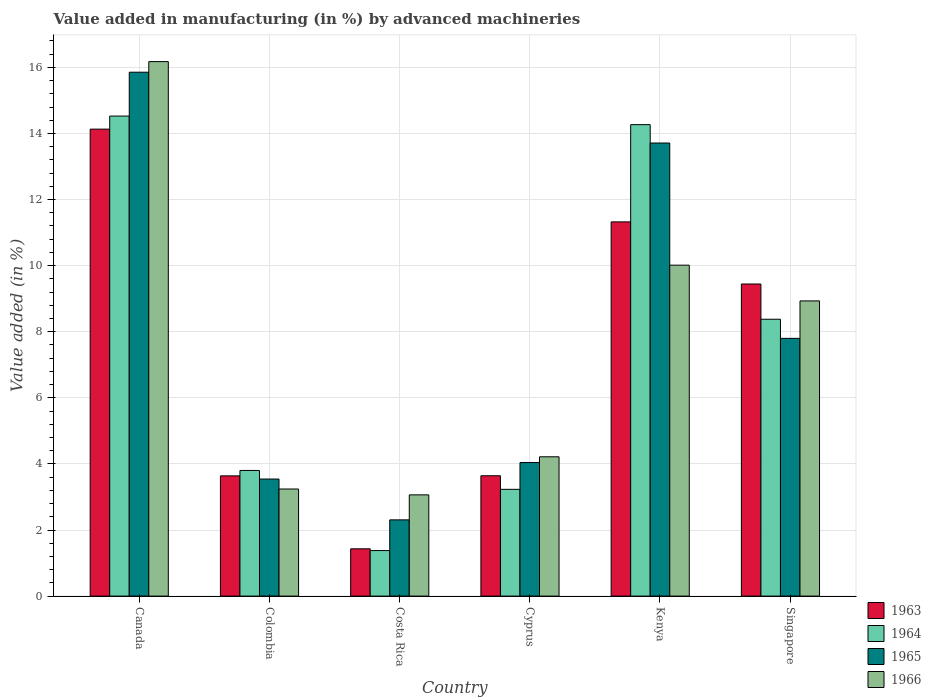How many different coloured bars are there?
Your response must be concise. 4. How many groups of bars are there?
Offer a very short reply. 6. Are the number of bars on each tick of the X-axis equal?
Offer a terse response. Yes. What is the label of the 6th group of bars from the left?
Keep it short and to the point. Singapore. In how many cases, is the number of bars for a given country not equal to the number of legend labels?
Your response must be concise. 0. What is the percentage of value added in manufacturing by advanced machineries in 1963 in Canada?
Give a very brief answer. 14.13. Across all countries, what is the maximum percentage of value added in manufacturing by advanced machineries in 1963?
Provide a short and direct response. 14.13. Across all countries, what is the minimum percentage of value added in manufacturing by advanced machineries in 1966?
Make the answer very short. 3.06. In which country was the percentage of value added in manufacturing by advanced machineries in 1963 minimum?
Provide a short and direct response. Costa Rica. What is the total percentage of value added in manufacturing by advanced machineries in 1966 in the graph?
Make the answer very short. 45.64. What is the difference between the percentage of value added in manufacturing by advanced machineries in 1963 in Canada and that in Cyprus?
Make the answer very short. 10.49. What is the difference between the percentage of value added in manufacturing by advanced machineries in 1966 in Costa Rica and the percentage of value added in manufacturing by advanced machineries in 1964 in Colombia?
Your answer should be very brief. -0.74. What is the average percentage of value added in manufacturing by advanced machineries in 1965 per country?
Ensure brevity in your answer.  7.88. What is the difference between the percentage of value added in manufacturing by advanced machineries of/in 1964 and percentage of value added in manufacturing by advanced machineries of/in 1963 in Canada?
Provide a short and direct response. 0.4. In how many countries, is the percentage of value added in manufacturing by advanced machineries in 1964 greater than 11.2 %?
Ensure brevity in your answer.  2. What is the ratio of the percentage of value added in manufacturing by advanced machineries in 1966 in Canada to that in Kenya?
Offer a very short reply. 1.62. What is the difference between the highest and the second highest percentage of value added in manufacturing by advanced machineries in 1963?
Ensure brevity in your answer.  -1.88. What is the difference between the highest and the lowest percentage of value added in manufacturing by advanced machineries in 1964?
Provide a short and direct response. 13.15. Is it the case that in every country, the sum of the percentage of value added in manufacturing by advanced machineries in 1966 and percentage of value added in manufacturing by advanced machineries in 1964 is greater than the sum of percentage of value added in manufacturing by advanced machineries in 1965 and percentage of value added in manufacturing by advanced machineries in 1963?
Your answer should be compact. No. What does the 3rd bar from the left in Colombia represents?
Your response must be concise. 1965. What does the 2nd bar from the right in Costa Rica represents?
Give a very brief answer. 1965. How many bars are there?
Your answer should be very brief. 24. How many countries are there in the graph?
Offer a terse response. 6. Does the graph contain grids?
Offer a terse response. Yes. How are the legend labels stacked?
Keep it short and to the point. Vertical. What is the title of the graph?
Ensure brevity in your answer.  Value added in manufacturing (in %) by advanced machineries. What is the label or title of the Y-axis?
Your response must be concise. Value added (in %). What is the Value added (in %) of 1963 in Canada?
Your answer should be very brief. 14.13. What is the Value added (in %) of 1964 in Canada?
Keep it short and to the point. 14.53. What is the Value added (in %) in 1965 in Canada?
Provide a short and direct response. 15.85. What is the Value added (in %) of 1966 in Canada?
Your answer should be compact. 16.17. What is the Value added (in %) in 1963 in Colombia?
Offer a very short reply. 3.64. What is the Value added (in %) of 1964 in Colombia?
Offer a terse response. 3.8. What is the Value added (in %) in 1965 in Colombia?
Your answer should be very brief. 3.54. What is the Value added (in %) in 1966 in Colombia?
Keep it short and to the point. 3.24. What is the Value added (in %) in 1963 in Costa Rica?
Make the answer very short. 1.43. What is the Value added (in %) of 1964 in Costa Rica?
Your answer should be compact. 1.38. What is the Value added (in %) of 1965 in Costa Rica?
Make the answer very short. 2.31. What is the Value added (in %) of 1966 in Costa Rica?
Your response must be concise. 3.06. What is the Value added (in %) of 1963 in Cyprus?
Offer a terse response. 3.64. What is the Value added (in %) in 1964 in Cyprus?
Ensure brevity in your answer.  3.23. What is the Value added (in %) of 1965 in Cyprus?
Offer a very short reply. 4.04. What is the Value added (in %) in 1966 in Cyprus?
Your response must be concise. 4.22. What is the Value added (in %) in 1963 in Kenya?
Your answer should be very brief. 11.32. What is the Value added (in %) in 1964 in Kenya?
Provide a succinct answer. 14.27. What is the Value added (in %) of 1965 in Kenya?
Provide a succinct answer. 13.71. What is the Value added (in %) of 1966 in Kenya?
Provide a succinct answer. 10.01. What is the Value added (in %) of 1963 in Singapore?
Keep it short and to the point. 9.44. What is the Value added (in %) of 1964 in Singapore?
Give a very brief answer. 8.38. What is the Value added (in %) of 1965 in Singapore?
Make the answer very short. 7.8. What is the Value added (in %) in 1966 in Singapore?
Keep it short and to the point. 8.93. Across all countries, what is the maximum Value added (in %) of 1963?
Offer a terse response. 14.13. Across all countries, what is the maximum Value added (in %) of 1964?
Give a very brief answer. 14.53. Across all countries, what is the maximum Value added (in %) in 1965?
Your answer should be compact. 15.85. Across all countries, what is the maximum Value added (in %) in 1966?
Provide a succinct answer. 16.17. Across all countries, what is the minimum Value added (in %) of 1963?
Your answer should be compact. 1.43. Across all countries, what is the minimum Value added (in %) of 1964?
Your answer should be compact. 1.38. Across all countries, what is the minimum Value added (in %) of 1965?
Give a very brief answer. 2.31. Across all countries, what is the minimum Value added (in %) of 1966?
Offer a very short reply. 3.06. What is the total Value added (in %) in 1963 in the graph?
Offer a very short reply. 43.61. What is the total Value added (in %) in 1964 in the graph?
Provide a short and direct response. 45.58. What is the total Value added (in %) of 1965 in the graph?
Your answer should be compact. 47.25. What is the total Value added (in %) of 1966 in the graph?
Offer a terse response. 45.64. What is the difference between the Value added (in %) of 1963 in Canada and that in Colombia?
Make the answer very short. 10.49. What is the difference between the Value added (in %) in 1964 in Canada and that in Colombia?
Offer a very short reply. 10.72. What is the difference between the Value added (in %) in 1965 in Canada and that in Colombia?
Your response must be concise. 12.31. What is the difference between the Value added (in %) in 1966 in Canada and that in Colombia?
Provide a succinct answer. 12.93. What is the difference between the Value added (in %) of 1963 in Canada and that in Costa Rica?
Provide a short and direct response. 12.7. What is the difference between the Value added (in %) in 1964 in Canada and that in Costa Rica?
Offer a very short reply. 13.15. What is the difference between the Value added (in %) in 1965 in Canada and that in Costa Rica?
Offer a terse response. 13.55. What is the difference between the Value added (in %) of 1966 in Canada and that in Costa Rica?
Make the answer very short. 13.11. What is the difference between the Value added (in %) in 1963 in Canada and that in Cyprus?
Your response must be concise. 10.49. What is the difference between the Value added (in %) of 1964 in Canada and that in Cyprus?
Provide a succinct answer. 11.3. What is the difference between the Value added (in %) of 1965 in Canada and that in Cyprus?
Provide a short and direct response. 11.81. What is the difference between the Value added (in %) of 1966 in Canada and that in Cyprus?
Give a very brief answer. 11.96. What is the difference between the Value added (in %) of 1963 in Canada and that in Kenya?
Provide a short and direct response. 2.81. What is the difference between the Value added (in %) in 1964 in Canada and that in Kenya?
Your answer should be very brief. 0.26. What is the difference between the Value added (in %) in 1965 in Canada and that in Kenya?
Ensure brevity in your answer.  2.14. What is the difference between the Value added (in %) of 1966 in Canada and that in Kenya?
Your answer should be compact. 6.16. What is the difference between the Value added (in %) in 1963 in Canada and that in Singapore?
Keep it short and to the point. 4.69. What is the difference between the Value added (in %) of 1964 in Canada and that in Singapore?
Make the answer very short. 6.15. What is the difference between the Value added (in %) in 1965 in Canada and that in Singapore?
Offer a terse response. 8.05. What is the difference between the Value added (in %) of 1966 in Canada and that in Singapore?
Offer a very short reply. 7.24. What is the difference between the Value added (in %) in 1963 in Colombia and that in Costa Rica?
Offer a terse response. 2.21. What is the difference between the Value added (in %) in 1964 in Colombia and that in Costa Rica?
Your answer should be very brief. 2.42. What is the difference between the Value added (in %) of 1965 in Colombia and that in Costa Rica?
Your answer should be very brief. 1.24. What is the difference between the Value added (in %) of 1966 in Colombia and that in Costa Rica?
Give a very brief answer. 0.18. What is the difference between the Value added (in %) in 1963 in Colombia and that in Cyprus?
Provide a succinct answer. -0. What is the difference between the Value added (in %) of 1964 in Colombia and that in Cyprus?
Provide a short and direct response. 0.57. What is the difference between the Value added (in %) of 1965 in Colombia and that in Cyprus?
Make the answer very short. -0.5. What is the difference between the Value added (in %) in 1966 in Colombia and that in Cyprus?
Ensure brevity in your answer.  -0.97. What is the difference between the Value added (in %) in 1963 in Colombia and that in Kenya?
Your answer should be very brief. -7.69. What is the difference between the Value added (in %) of 1964 in Colombia and that in Kenya?
Give a very brief answer. -10.47. What is the difference between the Value added (in %) in 1965 in Colombia and that in Kenya?
Provide a short and direct response. -10.17. What is the difference between the Value added (in %) in 1966 in Colombia and that in Kenya?
Your response must be concise. -6.77. What is the difference between the Value added (in %) of 1963 in Colombia and that in Singapore?
Give a very brief answer. -5.81. What is the difference between the Value added (in %) of 1964 in Colombia and that in Singapore?
Offer a terse response. -4.58. What is the difference between the Value added (in %) of 1965 in Colombia and that in Singapore?
Your response must be concise. -4.26. What is the difference between the Value added (in %) of 1966 in Colombia and that in Singapore?
Give a very brief answer. -5.69. What is the difference between the Value added (in %) of 1963 in Costa Rica and that in Cyprus?
Your answer should be very brief. -2.21. What is the difference between the Value added (in %) of 1964 in Costa Rica and that in Cyprus?
Make the answer very short. -1.85. What is the difference between the Value added (in %) of 1965 in Costa Rica and that in Cyprus?
Give a very brief answer. -1.73. What is the difference between the Value added (in %) in 1966 in Costa Rica and that in Cyprus?
Your answer should be compact. -1.15. What is the difference between the Value added (in %) of 1963 in Costa Rica and that in Kenya?
Your answer should be compact. -9.89. What is the difference between the Value added (in %) in 1964 in Costa Rica and that in Kenya?
Ensure brevity in your answer.  -12.89. What is the difference between the Value added (in %) in 1965 in Costa Rica and that in Kenya?
Offer a very short reply. -11.4. What is the difference between the Value added (in %) in 1966 in Costa Rica and that in Kenya?
Give a very brief answer. -6.95. What is the difference between the Value added (in %) of 1963 in Costa Rica and that in Singapore?
Ensure brevity in your answer.  -8.01. What is the difference between the Value added (in %) of 1964 in Costa Rica and that in Singapore?
Offer a very short reply. -7. What is the difference between the Value added (in %) of 1965 in Costa Rica and that in Singapore?
Give a very brief answer. -5.49. What is the difference between the Value added (in %) of 1966 in Costa Rica and that in Singapore?
Your answer should be compact. -5.87. What is the difference between the Value added (in %) of 1963 in Cyprus and that in Kenya?
Keep it short and to the point. -7.68. What is the difference between the Value added (in %) in 1964 in Cyprus and that in Kenya?
Provide a succinct answer. -11.04. What is the difference between the Value added (in %) in 1965 in Cyprus and that in Kenya?
Ensure brevity in your answer.  -9.67. What is the difference between the Value added (in %) of 1966 in Cyprus and that in Kenya?
Your answer should be very brief. -5.8. What is the difference between the Value added (in %) of 1963 in Cyprus and that in Singapore?
Keep it short and to the point. -5.8. What is the difference between the Value added (in %) of 1964 in Cyprus and that in Singapore?
Your answer should be very brief. -5.15. What is the difference between the Value added (in %) in 1965 in Cyprus and that in Singapore?
Make the answer very short. -3.76. What is the difference between the Value added (in %) of 1966 in Cyprus and that in Singapore?
Provide a short and direct response. -4.72. What is the difference between the Value added (in %) in 1963 in Kenya and that in Singapore?
Your answer should be compact. 1.88. What is the difference between the Value added (in %) of 1964 in Kenya and that in Singapore?
Give a very brief answer. 5.89. What is the difference between the Value added (in %) of 1965 in Kenya and that in Singapore?
Offer a very short reply. 5.91. What is the difference between the Value added (in %) in 1966 in Kenya and that in Singapore?
Your answer should be compact. 1.08. What is the difference between the Value added (in %) in 1963 in Canada and the Value added (in %) in 1964 in Colombia?
Provide a short and direct response. 10.33. What is the difference between the Value added (in %) in 1963 in Canada and the Value added (in %) in 1965 in Colombia?
Keep it short and to the point. 10.59. What is the difference between the Value added (in %) in 1963 in Canada and the Value added (in %) in 1966 in Colombia?
Your answer should be compact. 10.89. What is the difference between the Value added (in %) in 1964 in Canada and the Value added (in %) in 1965 in Colombia?
Your answer should be compact. 10.98. What is the difference between the Value added (in %) of 1964 in Canada and the Value added (in %) of 1966 in Colombia?
Ensure brevity in your answer.  11.29. What is the difference between the Value added (in %) in 1965 in Canada and the Value added (in %) in 1966 in Colombia?
Your answer should be very brief. 12.61. What is the difference between the Value added (in %) in 1963 in Canada and the Value added (in %) in 1964 in Costa Rica?
Your answer should be very brief. 12.75. What is the difference between the Value added (in %) in 1963 in Canada and the Value added (in %) in 1965 in Costa Rica?
Offer a terse response. 11.82. What is the difference between the Value added (in %) of 1963 in Canada and the Value added (in %) of 1966 in Costa Rica?
Your answer should be compact. 11.07. What is the difference between the Value added (in %) in 1964 in Canada and the Value added (in %) in 1965 in Costa Rica?
Your response must be concise. 12.22. What is the difference between the Value added (in %) in 1964 in Canada and the Value added (in %) in 1966 in Costa Rica?
Your answer should be compact. 11.46. What is the difference between the Value added (in %) in 1965 in Canada and the Value added (in %) in 1966 in Costa Rica?
Offer a terse response. 12.79. What is the difference between the Value added (in %) of 1963 in Canada and the Value added (in %) of 1964 in Cyprus?
Your response must be concise. 10.9. What is the difference between the Value added (in %) of 1963 in Canada and the Value added (in %) of 1965 in Cyprus?
Offer a very short reply. 10.09. What is the difference between the Value added (in %) of 1963 in Canada and the Value added (in %) of 1966 in Cyprus?
Offer a very short reply. 9.92. What is the difference between the Value added (in %) in 1964 in Canada and the Value added (in %) in 1965 in Cyprus?
Offer a very short reply. 10.49. What is the difference between the Value added (in %) in 1964 in Canada and the Value added (in %) in 1966 in Cyprus?
Provide a succinct answer. 10.31. What is the difference between the Value added (in %) in 1965 in Canada and the Value added (in %) in 1966 in Cyprus?
Provide a succinct answer. 11.64. What is the difference between the Value added (in %) in 1963 in Canada and the Value added (in %) in 1964 in Kenya?
Your answer should be compact. -0.14. What is the difference between the Value added (in %) of 1963 in Canada and the Value added (in %) of 1965 in Kenya?
Provide a succinct answer. 0.42. What is the difference between the Value added (in %) of 1963 in Canada and the Value added (in %) of 1966 in Kenya?
Provide a succinct answer. 4.12. What is the difference between the Value added (in %) in 1964 in Canada and the Value added (in %) in 1965 in Kenya?
Your answer should be compact. 0.82. What is the difference between the Value added (in %) in 1964 in Canada and the Value added (in %) in 1966 in Kenya?
Ensure brevity in your answer.  4.51. What is the difference between the Value added (in %) of 1965 in Canada and the Value added (in %) of 1966 in Kenya?
Provide a succinct answer. 5.84. What is the difference between the Value added (in %) of 1963 in Canada and the Value added (in %) of 1964 in Singapore?
Give a very brief answer. 5.75. What is the difference between the Value added (in %) of 1963 in Canada and the Value added (in %) of 1965 in Singapore?
Your response must be concise. 6.33. What is the difference between the Value added (in %) in 1963 in Canada and the Value added (in %) in 1966 in Singapore?
Your answer should be very brief. 5.2. What is the difference between the Value added (in %) in 1964 in Canada and the Value added (in %) in 1965 in Singapore?
Keep it short and to the point. 6.73. What is the difference between the Value added (in %) in 1964 in Canada and the Value added (in %) in 1966 in Singapore?
Your answer should be very brief. 5.59. What is the difference between the Value added (in %) in 1965 in Canada and the Value added (in %) in 1966 in Singapore?
Your response must be concise. 6.92. What is the difference between the Value added (in %) of 1963 in Colombia and the Value added (in %) of 1964 in Costa Rica?
Offer a very short reply. 2.26. What is the difference between the Value added (in %) in 1963 in Colombia and the Value added (in %) in 1965 in Costa Rica?
Your answer should be compact. 1.33. What is the difference between the Value added (in %) of 1963 in Colombia and the Value added (in %) of 1966 in Costa Rica?
Your answer should be compact. 0.57. What is the difference between the Value added (in %) of 1964 in Colombia and the Value added (in %) of 1965 in Costa Rica?
Ensure brevity in your answer.  1.49. What is the difference between the Value added (in %) in 1964 in Colombia and the Value added (in %) in 1966 in Costa Rica?
Your response must be concise. 0.74. What is the difference between the Value added (in %) in 1965 in Colombia and the Value added (in %) in 1966 in Costa Rica?
Keep it short and to the point. 0.48. What is the difference between the Value added (in %) in 1963 in Colombia and the Value added (in %) in 1964 in Cyprus?
Offer a terse response. 0.41. What is the difference between the Value added (in %) of 1963 in Colombia and the Value added (in %) of 1965 in Cyprus?
Your response must be concise. -0.4. What is the difference between the Value added (in %) of 1963 in Colombia and the Value added (in %) of 1966 in Cyprus?
Keep it short and to the point. -0.58. What is the difference between the Value added (in %) in 1964 in Colombia and the Value added (in %) in 1965 in Cyprus?
Give a very brief answer. -0.24. What is the difference between the Value added (in %) of 1964 in Colombia and the Value added (in %) of 1966 in Cyprus?
Offer a terse response. -0.41. What is the difference between the Value added (in %) in 1965 in Colombia and the Value added (in %) in 1966 in Cyprus?
Your response must be concise. -0.67. What is the difference between the Value added (in %) of 1963 in Colombia and the Value added (in %) of 1964 in Kenya?
Your answer should be very brief. -10.63. What is the difference between the Value added (in %) of 1963 in Colombia and the Value added (in %) of 1965 in Kenya?
Your answer should be very brief. -10.07. What is the difference between the Value added (in %) in 1963 in Colombia and the Value added (in %) in 1966 in Kenya?
Provide a succinct answer. -6.38. What is the difference between the Value added (in %) in 1964 in Colombia and the Value added (in %) in 1965 in Kenya?
Make the answer very short. -9.91. What is the difference between the Value added (in %) of 1964 in Colombia and the Value added (in %) of 1966 in Kenya?
Offer a very short reply. -6.21. What is the difference between the Value added (in %) in 1965 in Colombia and the Value added (in %) in 1966 in Kenya?
Ensure brevity in your answer.  -6.47. What is the difference between the Value added (in %) in 1963 in Colombia and the Value added (in %) in 1964 in Singapore?
Make the answer very short. -4.74. What is the difference between the Value added (in %) in 1963 in Colombia and the Value added (in %) in 1965 in Singapore?
Make the answer very short. -4.16. What is the difference between the Value added (in %) in 1963 in Colombia and the Value added (in %) in 1966 in Singapore?
Ensure brevity in your answer.  -5.29. What is the difference between the Value added (in %) of 1964 in Colombia and the Value added (in %) of 1965 in Singapore?
Offer a very short reply. -4. What is the difference between the Value added (in %) of 1964 in Colombia and the Value added (in %) of 1966 in Singapore?
Ensure brevity in your answer.  -5.13. What is the difference between the Value added (in %) in 1965 in Colombia and the Value added (in %) in 1966 in Singapore?
Make the answer very short. -5.39. What is the difference between the Value added (in %) of 1963 in Costa Rica and the Value added (in %) of 1964 in Cyprus?
Keep it short and to the point. -1.8. What is the difference between the Value added (in %) in 1963 in Costa Rica and the Value added (in %) in 1965 in Cyprus?
Your answer should be compact. -2.61. What is the difference between the Value added (in %) of 1963 in Costa Rica and the Value added (in %) of 1966 in Cyprus?
Offer a very short reply. -2.78. What is the difference between the Value added (in %) of 1964 in Costa Rica and the Value added (in %) of 1965 in Cyprus?
Offer a very short reply. -2.66. What is the difference between the Value added (in %) in 1964 in Costa Rica and the Value added (in %) in 1966 in Cyprus?
Make the answer very short. -2.84. What is the difference between the Value added (in %) in 1965 in Costa Rica and the Value added (in %) in 1966 in Cyprus?
Provide a short and direct response. -1.91. What is the difference between the Value added (in %) in 1963 in Costa Rica and the Value added (in %) in 1964 in Kenya?
Offer a terse response. -12.84. What is the difference between the Value added (in %) of 1963 in Costa Rica and the Value added (in %) of 1965 in Kenya?
Give a very brief answer. -12.28. What is the difference between the Value added (in %) in 1963 in Costa Rica and the Value added (in %) in 1966 in Kenya?
Offer a very short reply. -8.58. What is the difference between the Value added (in %) in 1964 in Costa Rica and the Value added (in %) in 1965 in Kenya?
Offer a very short reply. -12.33. What is the difference between the Value added (in %) of 1964 in Costa Rica and the Value added (in %) of 1966 in Kenya?
Keep it short and to the point. -8.64. What is the difference between the Value added (in %) of 1965 in Costa Rica and the Value added (in %) of 1966 in Kenya?
Offer a very short reply. -7.71. What is the difference between the Value added (in %) of 1963 in Costa Rica and the Value added (in %) of 1964 in Singapore?
Offer a terse response. -6.95. What is the difference between the Value added (in %) of 1963 in Costa Rica and the Value added (in %) of 1965 in Singapore?
Offer a terse response. -6.37. What is the difference between the Value added (in %) of 1963 in Costa Rica and the Value added (in %) of 1966 in Singapore?
Offer a very short reply. -7.5. What is the difference between the Value added (in %) in 1964 in Costa Rica and the Value added (in %) in 1965 in Singapore?
Give a very brief answer. -6.42. What is the difference between the Value added (in %) of 1964 in Costa Rica and the Value added (in %) of 1966 in Singapore?
Your response must be concise. -7.55. What is the difference between the Value added (in %) of 1965 in Costa Rica and the Value added (in %) of 1966 in Singapore?
Ensure brevity in your answer.  -6.63. What is the difference between the Value added (in %) of 1963 in Cyprus and the Value added (in %) of 1964 in Kenya?
Your answer should be compact. -10.63. What is the difference between the Value added (in %) of 1963 in Cyprus and the Value added (in %) of 1965 in Kenya?
Provide a short and direct response. -10.07. What is the difference between the Value added (in %) in 1963 in Cyprus and the Value added (in %) in 1966 in Kenya?
Offer a terse response. -6.37. What is the difference between the Value added (in %) in 1964 in Cyprus and the Value added (in %) in 1965 in Kenya?
Your answer should be compact. -10.48. What is the difference between the Value added (in %) of 1964 in Cyprus and the Value added (in %) of 1966 in Kenya?
Keep it short and to the point. -6.78. What is the difference between the Value added (in %) in 1965 in Cyprus and the Value added (in %) in 1966 in Kenya?
Make the answer very short. -5.97. What is the difference between the Value added (in %) in 1963 in Cyprus and the Value added (in %) in 1964 in Singapore?
Make the answer very short. -4.74. What is the difference between the Value added (in %) in 1963 in Cyprus and the Value added (in %) in 1965 in Singapore?
Your response must be concise. -4.16. What is the difference between the Value added (in %) of 1963 in Cyprus and the Value added (in %) of 1966 in Singapore?
Your response must be concise. -5.29. What is the difference between the Value added (in %) of 1964 in Cyprus and the Value added (in %) of 1965 in Singapore?
Offer a very short reply. -4.57. What is the difference between the Value added (in %) in 1964 in Cyprus and the Value added (in %) in 1966 in Singapore?
Offer a very short reply. -5.7. What is the difference between the Value added (in %) in 1965 in Cyprus and the Value added (in %) in 1966 in Singapore?
Offer a terse response. -4.89. What is the difference between the Value added (in %) of 1963 in Kenya and the Value added (in %) of 1964 in Singapore?
Make the answer very short. 2.95. What is the difference between the Value added (in %) of 1963 in Kenya and the Value added (in %) of 1965 in Singapore?
Your answer should be very brief. 3.52. What is the difference between the Value added (in %) of 1963 in Kenya and the Value added (in %) of 1966 in Singapore?
Your answer should be compact. 2.39. What is the difference between the Value added (in %) of 1964 in Kenya and the Value added (in %) of 1965 in Singapore?
Your answer should be compact. 6.47. What is the difference between the Value added (in %) in 1964 in Kenya and the Value added (in %) in 1966 in Singapore?
Your answer should be compact. 5.33. What is the difference between the Value added (in %) of 1965 in Kenya and the Value added (in %) of 1966 in Singapore?
Keep it short and to the point. 4.78. What is the average Value added (in %) in 1963 per country?
Provide a short and direct response. 7.27. What is the average Value added (in %) in 1964 per country?
Keep it short and to the point. 7.6. What is the average Value added (in %) of 1965 per country?
Give a very brief answer. 7.88. What is the average Value added (in %) of 1966 per country?
Your answer should be very brief. 7.61. What is the difference between the Value added (in %) in 1963 and Value added (in %) in 1964 in Canada?
Offer a very short reply. -0.4. What is the difference between the Value added (in %) in 1963 and Value added (in %) in 1965 in Canada?
Ensure brevity in your answer.  -1.72. What is the difference between the Value added (in %) of 1963 and Value added (in %) of 1966 in Canada?
Make the answer very short. -2.04. What is the difference between the Value added (in %) of 1964 and Value added (in %) of 1965 in Canada?
Provide a succinct answer. -1.33. What is the difference between the Value added (in %) of 1964 and Value added (in %) of 1966 in Canada?
Your answer should be very brief. -1.65. What is the difference between the Value added (in %) in 1965 and Value added (in %) in 1966 in Canada?
Offer a terse response. -0.32. What is the difference between the Value added (in %) in 1963 and Value added (in %) in 1964 in Colombia?
Provide a succinct answer. -0.16. What is the difference between the Value added (in %) of 1963 and Value added (in %) of 1965 in Colombia?
Make the answer very short. 0.1. What is the difference between the Value added (in %) of 1963 and Value added (in %) of 1966 in Colombia?
Offer a very short reply. 0.4. What is the difference between the Value added (in %) in 1964 and Value added (in %) in 1965 in Colombia?
Keep it short and to the point. 0.26. What is the difference between the Value added (in %) in 1964 and Value added (in %) in 1966 in Colombia?
Keep it short and to the point. 0.56. What is the difference between the Value added (in %) of 1965 and Value added (in %) of 1966 in Colombia?
Give a very brief answer. 0.3. What is the difference between the Value added (in %) of 1963 and Value added (in %) of 1964 in Costa Rica?
Your response must be concise. 0.05. What is the difference between the Value added (in %) in 1963 and Value added (in %) in 1965 in Costa Rica?
Provide a short and direct response. -0.88. What is the difference between the Value added (in %) in 1963 and Value added (in %) in 1966 in Costa Rica?
Ensure brevity in your answer.  -1.63. What is the difference between the Value added (in %) of 1964 and Value added (in %) of 1965 in Costa Rica?
Your answer should be very brief. -0.93. What is the difference between the Value added (in %) of 1964 and Value added (in %) of 1966 in Costa Rica?
Offer a terse response. -1.69. What is the difference between the Value added (in %) in 1965 and Value added (in %) in 1966 in Costa Rica?
Offer a very short reply. -0.76. What is the difference between the Value added (in %) of 1963 and Value added (in %) of 1964 in Cyprus?
Provide a succinct answer. 0.41. What is the difference between the Value added (in %) in 1963 and Value added (in %) in 1965 in Cyprus?
Provide a succinct answer. -0.4. What is the difference between the Value added (in %) of 1963 and Value added (in %) of 1966 in Cyprus?
Offer a very short reply. -0.57. What is the difference between the Value added (in %) in 1964 and Value added (in %) in 1965 in Cyprus?
Offer a very short reply. -0.81. What is the difference between the Value added (in %) in 1964 and Value added (in %) in 1966 in Cyprus?
Keep it short and to the point. -0.98. What is the difference between the Value added (in %) of 1965 and Value added (in %) of 1966 in Cyprus?
Give a very brief answer. -0.17. What is the difference between the Value added (in %) of 1963 and Value added (in %) of 1964 in Kenya?
Make the answer very short. -2.94. What is the difference between the Value added (in %) of 1963 and Value added (in %) of 1965 in Kenya?
Offer a very short reply. -2.39. What is the difference between the Value added (in %) in 1963 and Value added (in %) in 1966 in Kenya?
Provide a succinct answer. 1.31. What is the difference between the Value added (in %) of 1964 and Value added (in %) of 1965 in Kenya?
Your answer should be compact. 0.56. What is the difference between the Value added (in %) of 1964 and Value added (in %) of 1966 in Kenya?
Provide a succinct answer. 4.25. What is the difference between the Value added (in %) of 1965 and Value added (in %) of 1966 in Kenya?
Your answer should be very brief. 3.7. What is the difference between the Value added (in %) in 1963 and Value added (in %) in 1964 in Singapore?
Your answer should be compact. 1.07. What is the difference between the Value added (in %) in 1963 and Value added (in %) in 1965 in Singapore?
Give a very brief answer. 1.64. What is the difference between the Value added (in %) in 1963 and Value added (in %) in 1966 in Singapore?
Your response must be concise. 0.51. What is the difference between the Value added (in %) of 1964 and Value added (in %) of 1965 in Singapore?
Make the answer very short. 0.58. What is the difference between the Value added (in %) in 1964 and Value added (in %) in 1966 in Singapore?
Offer a very short reply. -0.55. What is the difference between the Value added (in %) of 1965 and Value added (in %) of 1966 in Singapore?
Give a very brief answer. -1.13. What is the ratio of the Value added (in %) of 1963 in Canada to that in Colombia?
Ensure brevity in your answer.  3.88. What is the ratio of the Value added (in %) of 1964 in Canada to that in Colombia?
Your answer should be compact. 3.82. What is the ratio of the Value added (in %) in 1965 in Canada to that in Colombia?
Make the answer very short. 4.48. What is the ratio of the Value added (in %) of 1966 in Canada to that in Colombia?
Your response must be concise. 4.99. What is the ratio of the Value added (in %) of 1963 in Canada to that in Costa Rica?
Offer a terse response. 9.87. What is the ratio of the Value added (in %) in 1964 in Canada to that in Costa Rica?
Your response must be concise. 10.54. What is the ratio of the Value added (in %) in 1965 in Canada to that in Costa Rica?
Your answer should be very brief. 6.87. What is the ratio of the Value added (in %) of 1966 in Canada to that in Costa Rica?
Your answer should be very brief. 5.28. What is the ratio of the Value added (in %) of 1963 in Canada to that in Cyprus?
Keep it short and to the point. 3.88. What is the ratio of the Value added (in %) of 1964 in Canada to that in Cyprus?
Your response must be concise. 4.5. What is the ratio of the Value added (in %) of 1965 in Canada to that in Cyprus?
Make the answer very short. 3.92. What is the ratio of the Value added (in %) in 1966 in Canada to that in Cyprus?
Make the answer very short. 3.84. What is the ratio of the Value added (in %) of 1963 in Canada to that in Kenya?
Your response must be concise. 1.25. What is the ratio of the Value added (in %) in 1964 in Canada to that in Kenya?
Your answer should be very brief. 1.02. What is the ratio of the Value added (in %) of 1965 in Canada to that in Kenya?
Provide a succinct answer. 1.16. What is the ratio of the Value added (in %) in 1966 in Canada to that in Kenya?
Offer a terse response. 1.62. What is the ratio of the Value added (in %) in 1963 in Canada to that in Singapore?
Provide a succinct answer. 1.5. What is the ratio of the Value added (in %) in 1964 in Canada to that in Singapore?
Provide a succinct answer. 1.73. What is the ratio of the Value added (in %) of 1965 in Canada to that in Singapore?
Your response must be concise. 2.03. What is the ratio of the Value added (in %) of 1966 in Canada to that in Singapore?
Offer a very short reply. 1.81. What is the ratio of the Value added (in %) of 1963 in Colombia to that in Costa Rica?
Give a very brief answer. 2.54. What is the ratio of the Value added (in %) of 1964 in Colombia to that in Costa Rica?
Ensure brevity in your answer.  2.76. What is the ratio of the Value added (in %) of 1965 in Colombia to that in Costa Rica?
Ensure brevity in your answer.  1.54. What is the ratio of the Value added (in %) of 1966 in Colombia to that in Costa Rica?
Your response must be concise. 1.06. What is the ratio of the Value added (in %) of 1964 in Colombia to that in Cyprus?
Give a very brief answer. 1.18. What is the ratio of the Value added (in %) of 1965 in Colombia to that in Cyprus?
Your answer should be very brief. 0.88. What is the ratio of the Value added (in %) in 1966 in Colombia to that in Cyprus?
Offer a very short reply. 0.77. What is the ratio of the Value added (in %) in 1963 in Colombia to that in Kenya?
Keep it short and to the point. 0.32. What is the ratio of the Value added (in %) in 1964 in Colombia to that in Kenya?
Make the answer very short. 0.27. What is the ratio of the Value added (in %) in 1965 in Colombia to that in Kenya?
Your response must be concise. 0.26. What is the ratio of the Value added (in %) in 1966 in Colombia to that in Kenya?
Your response must be concise. 0.32. What is the ratio of the Value added (in %) in 1963 in Colombia to that in Singapore?
Your answer should be very brief. 0.39. What is the ratio of the Value added (in %) of 1964 in Colombia to that in Singapore?
Provide a short and direct response. 0.45. What is the ratio of the Value added (in %) in 1965 in Colombia to that in Singapore?
Ensure brevity in your answer.  0.45. What is the ratio of the Value added (in %) in 1966 in Colombia to that in Singapore?
Ensure brevity in your answer.  0.36. What is the ratio of the Value added (in %) in 1963 in Costa Rica to that in Cyprus?
Provide a short and direct response. 0.39. What is the ratio of the Value added (in %) of 1964 in Costa Rica to that in Cyprus?
Ensure brevity in your answer.  0.43. What is the ratio of the Value added (in %) in 1965 in Costa Rica to that in Cyprus?
Your answer should be very brief. 0.57. What is the ratio of the Value added (in %) in 1966 in Costa Rica to that in Cyprus?
Keep it short and to the point. 0.73. What is the ratio of the Value added (in %) of 1963 in Costa Rica to that in Kenya?
Your response must be concise. 0.13. What is the ratio of the Value added (in %) in 1964 in Costa Rica to that in Kenya?
Your answer should be very brief. 0.1. What is the ratio of the Value added (in %) of 1965 in Costa Rica to that in Kenya?
Make the answer very short. 0.17. What is the ratio of the Value added (in %) of 1966 in Costa Rica to that in Kenya?
Provide a succinct answer. 0.31. What is the ratio of the Value added (in %) in 1963 in Costa Rica to that in Singapore?
Keep it short and to the point. 0.15. What is the ratio of the Value added (in %) of 1964 in Costa Rica to that in Singapore?
Give a very brief answer. 0.16. What is the ratio of the Value added (in %) in 1965 in Costa Rica to that in Singapore?
Make the answer very short. 0.3. What is the ratio of the Value added (in %) of 1966 in Costa Rica to that in Singapore?
Your response must be concise. 0.34. What is the ratio of the Value added (in %) in 1963 in Cyprus to that in Kenya?
Ensure brevity in your answer.  0.32. What is the ratio of the Value added (in %) in 1964 in Cyprus to that in Kenya?
Your response must be concise. 0.23. What is the ratio of the Value added (in %) in 1965 in Cyprus to that in Kenya?
Your answer should be compact. 0.29. What is the ratio of the Value added (in %) in 1966 in Cyprus to that in Kenya?
Your answer should be compact. 0.42. What is the ratio of the Value added (in %) in 1963 in Cyprus to that in Singapore?
Give a very brief answer. 0.39. What is the ratio of the Value added (in %) of 1964 in Cyprus to that in Singapore?
Ensure brevity in your answer.  0.39. What is the ratio of the Value added (in %) of 1965 in Cyprus to that in Singapore?
Ensure brevity in your answer.  0.52. What is the ratio of the Value added (in %) in 1966 in Cyprus to that in Singapore?
Make the answer very short. 0.47. What is the ratio of the Value added (in %) in 1963 in Kenya to that in Singapore?
Keep it short and to the point. 1.2. What is the ratio of the Value added (in %) of 1964 in Kenya to that in Singapore?
Ensure brevity in your answer.  1.7. What is the ratio of the Value added (in %) of 1965 in Kenya to that in Singapore?
Keep it short and to the point. 1.76. What is the ratio of the Value added (in %) of 1966 in Kenya to that in Singapore?
Provide a succinct answer. 1.12. What is the difference between the highest and the second highest Value added (in %) of 1963?
Offer a very short reply. 2.81. What is the difference between the highest and the second highest Value added (in %) in 1964?
Provide a short and direct response. 0.26. What is the difference between the highest and the second highest Value added (in %) in 1965?
Provide a succinct answer. 2.14. What is the difference between the highest and the second highest Value added (in %) in 1966?
Ensure brevity in your answer.  6.16. What is the difference between the highest and the lowest Value added (in %) of 1963?
Make the answer very short. 12.7. What is the difference between the highest and the lowest Value added (in %) in 1964?
Offer a very short reply. 13.15. What is the difference between the highest and the lowest Value added (in %) of 1965?
Your answer should be compact. 13.55. What is the difference between the highest and the lowest Value added (in %) of 1966?
Your answer should be very brief. 13.11. 